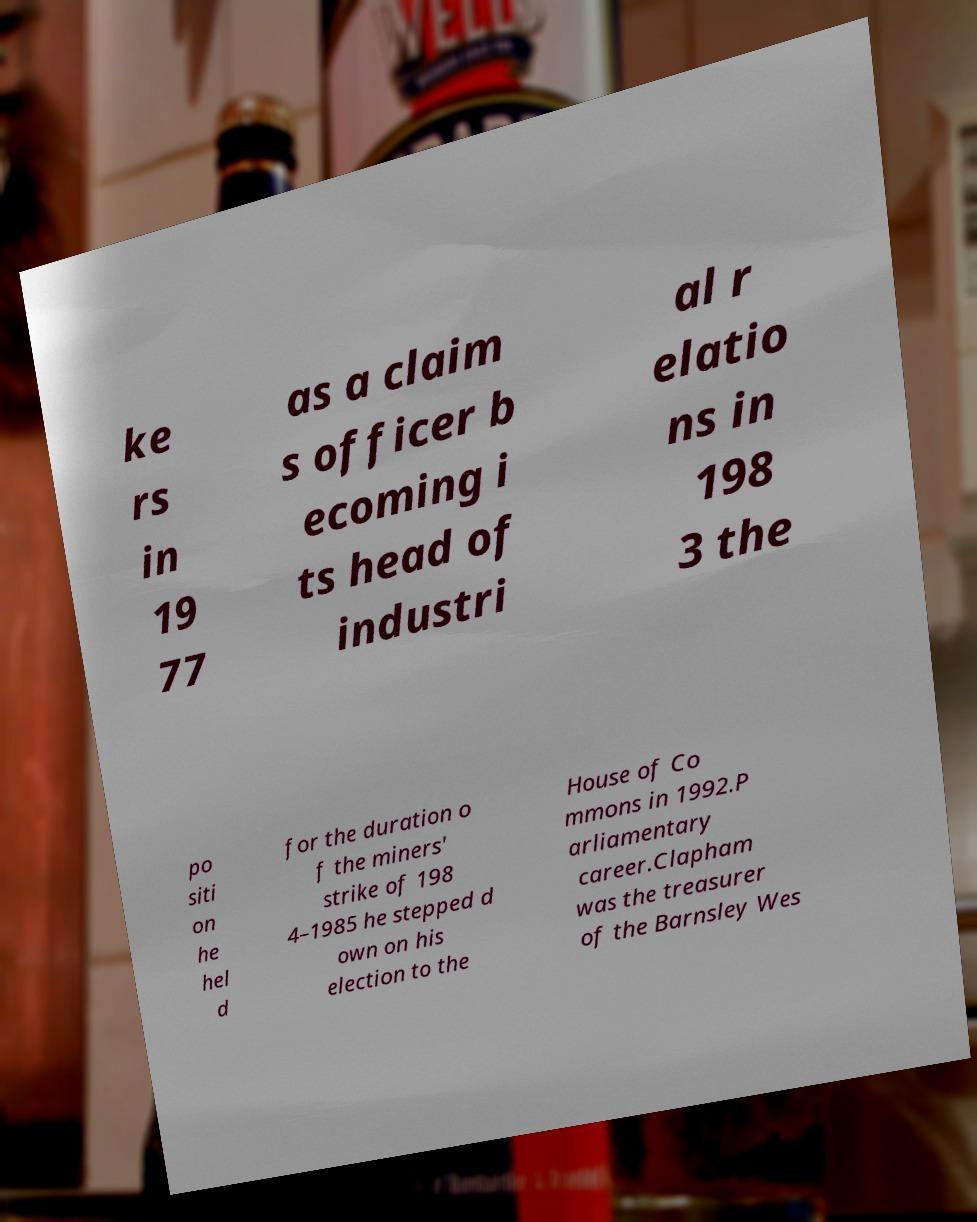Could you extract and type out the text from this image? ke rs in 19 77 as a claim s officer b ecoming i ts head of industri al r elatio ns in 198 3 the po siti on he hel d for the duration o f the miners' strike of 198 4–1985 he stepped d own on his election to the House of Co mmons in 1992.P arliamentary career.Clapham was the treasurer of the Barnsley Wes 